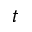Convert formula to latex. <formula><loc_0><loc_0><loc_500><loc_500>t</formula> 